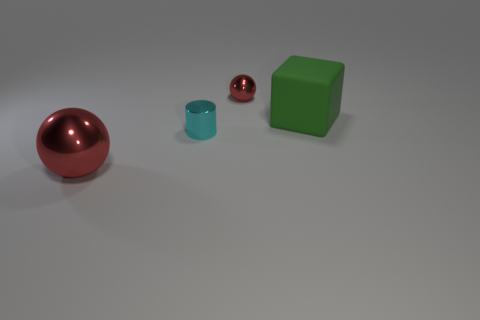Add 3 yellow spheres. How many objects exist? 7 Subtract all cylinders. How many objects are left? 3 Subtract all green spheres. Subtract all purple blocks. How many spheres are left? 2 Subtract all tiny purple matte cubes. Subtract all large green rubber cubes. How many objects are left? 3 Add 3 large green things. How many large green things are left? 4 Add 1 small metal things. How many small metal things exist? 3 Subtract 0 brown blocks. How many objects are left? 4 